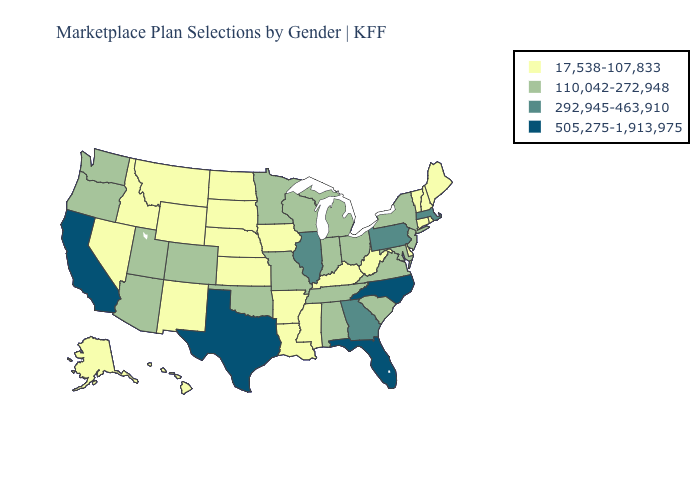Among the states that border North Carolina , does Virginia have the lowest value?
Write a very short answer. Yes. What is the value of North Carolina?
Give a very brief answer. 505,275-1,913,975. Name the states that have a value in the range 505,275-1,913,975?
Be succinct. California, Florida, North Carolina, Texas. Does Washington have the same value as South Carolina?
Quick response, please. Yes. Which states have the lowest value in the USA?
Give a very brief answer. Alaska, Arkansas, Connecticut, Delaware, Hawaii, Idaho, Iowa, Kansas, Kentucky, Louisiana, Maine, Mississippi, Montana, Nebraska, Nevada, New Hampshire, New Mexico, North Dakota, Rhode Island, South Dakota, Vermont, West Virginia, Wyoming. What is the value of Kansas?
Short answer required. 17,538-107,833. Does the map have missing data?
Write a very short answer. No. What is the value of South Carolina?
Short answer required. 110,042-272,948. What is the value of Utah?
Be succinct. 110,042-272,948. What is the value of Nevada?
Concise answer only. 17,538-107,833. Name the states that have a value in the range 17,538-107,833?
Give a very brief answer. Alaska, Arkansas, Connecticut, Delaware, Hawaii, Idaho, Iowa, Kansas, Kentucky, Louisiana, Maine, Mississippi, Montana, Nebraska, Nevada, New Hampshire, New Mexico, North Dakota, Rhode Island, South Dakota, Vermont, West Virginia, Wyoming. What is the highest value in the MidWest ?
Keep it brief. 292,945-463,910. Name the states that have a value in the range 110,042-272,948?
Answer briefly. Alabama, Arizona, Colorado, Indiana, Maryland, Michigan, Minnesota, Missouri, New Jersey, New York, Ohio, Oklahoma, Oregon, South Carolina, Tennessee, Utah, Virginia, Washington, Wisconsin. Which states hav the highest value in the South?
Concise answer only. Florida, North Carolina, Texas. What is the value of Ohio?
Keep it brief. 110,042-272,948. 